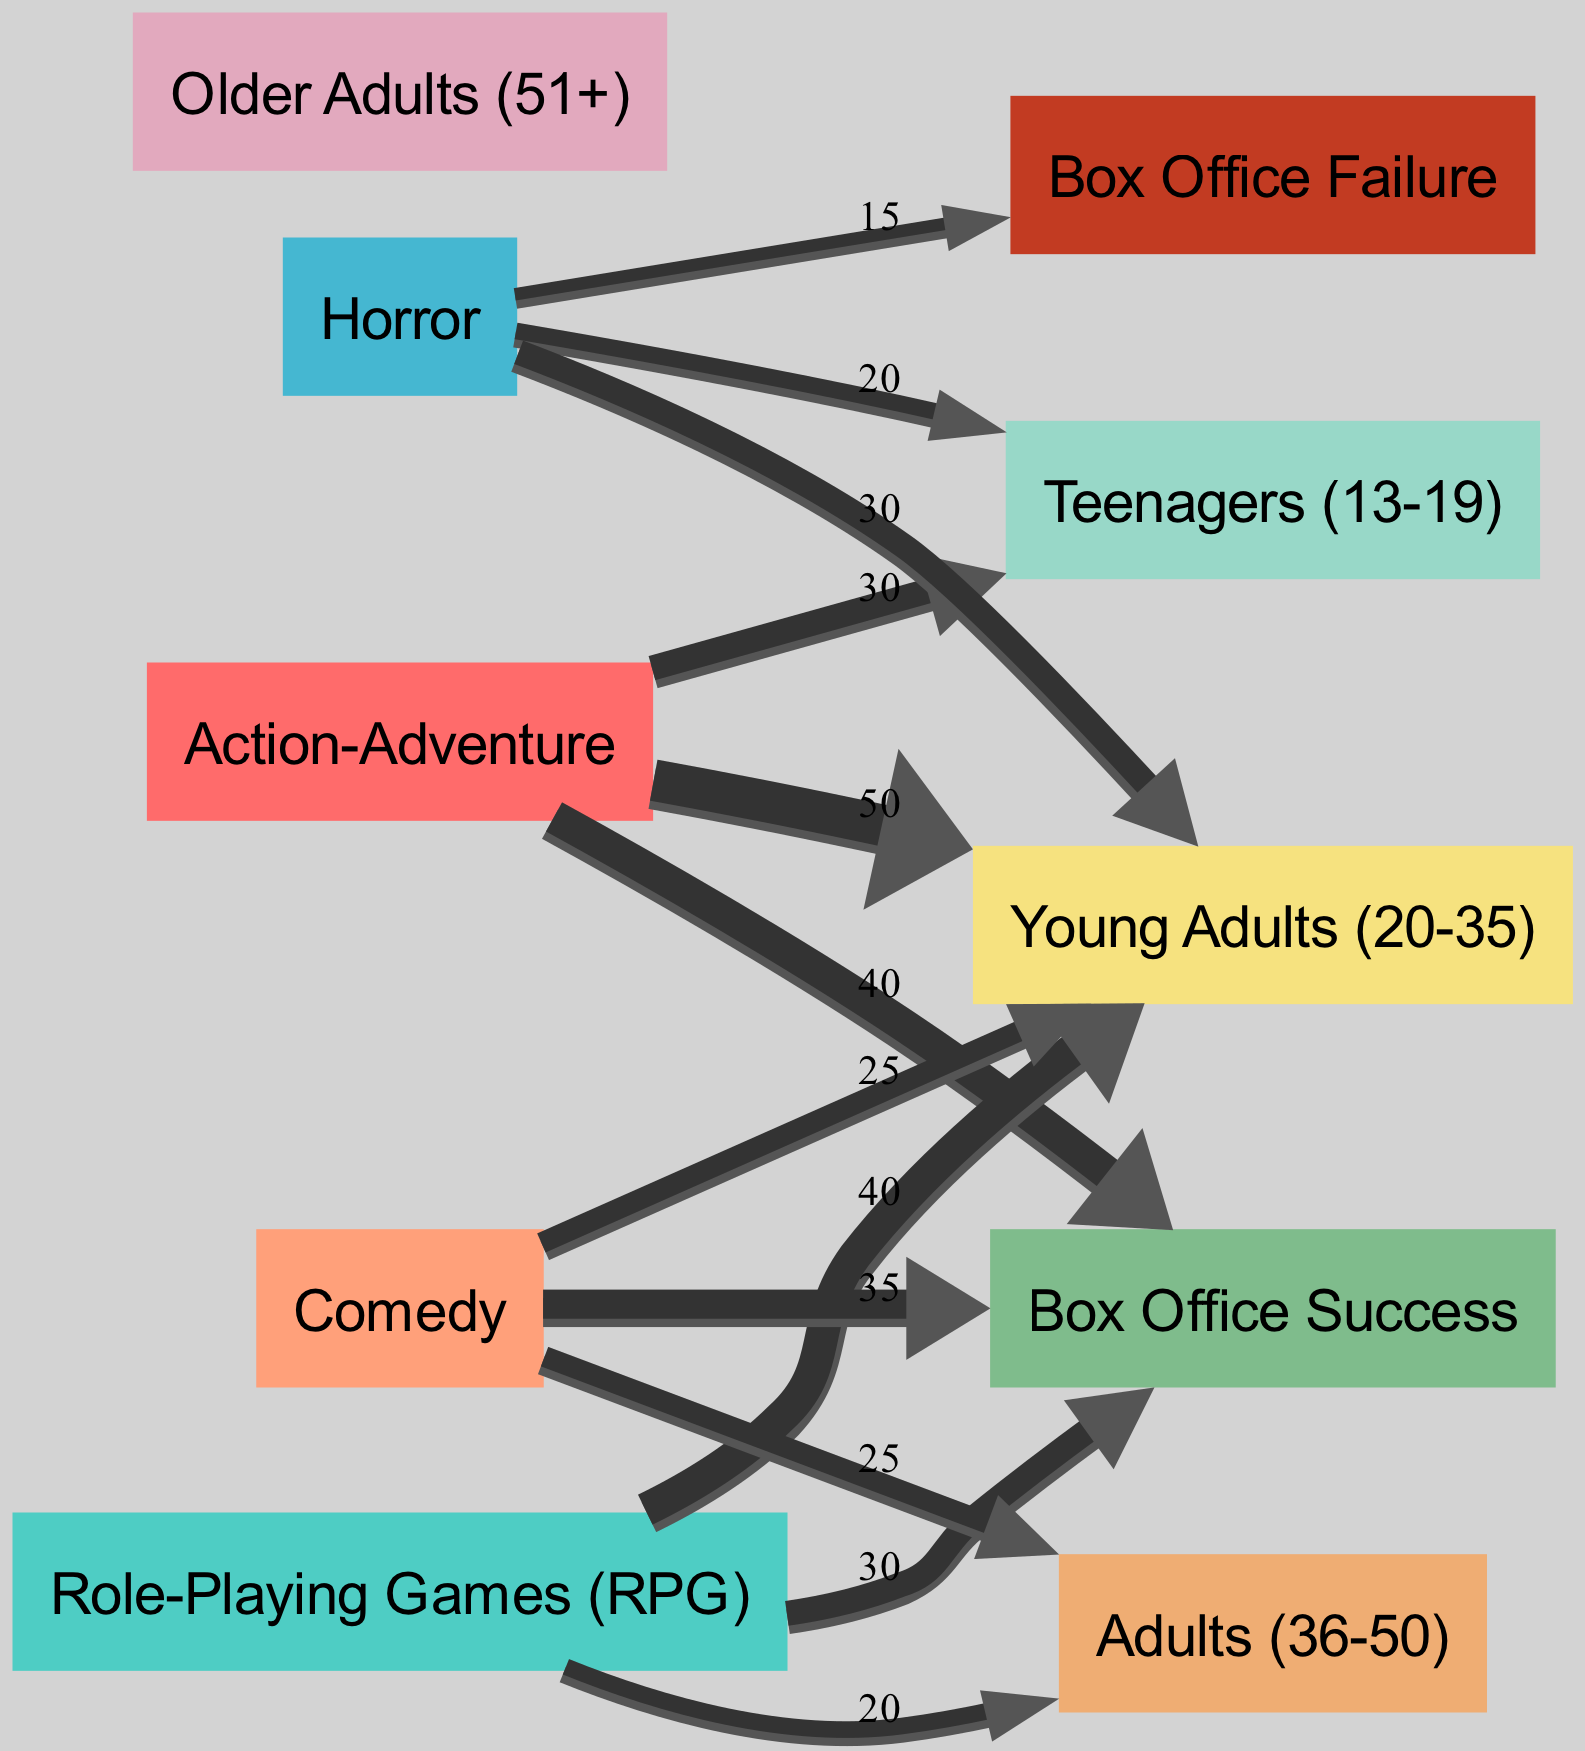What age group has the highest association with Action-Adventure films? By examining the outgoing connections from the Action-Adventure node, young adults have the highest value of 50, indicating they are the primary age group associated with this genre.
Answer: Young Adults What is the total number of edges in the diagram? There are four genres and two outcomes, with outgoing connections representing audience demographic values. The counted edges linking genres to demographics and outcomes total to ten edges depicted in the diagram.
Answer: 10 Which genre has the lowest value linked to Box Office Failure? The genre Horror has a value of 15 linked to Box Office Failure, which is the lowest among all genres represented in the diagram as it connects directly with that outcome.
Answer: Horror What is the value of teenagers associated with Horror films? The diagram shows that the connection from Horror to Teenagers has a value of 20, indicating the number of teenagers engaged with horror films.
Answer: 20 Which age group has the highest association with Comedy films? By analyzing the flows from the Comedy node, it can be noted that the Young Adults and Adults age groups both share a value of 25, but the total value flowing from Comedy indicates the highest demographic impact from young adults as they contribute heavily in the majority of cases.
Answer: Young Adults What is the total value of young adults in Comedy and RPG films combined? The Comedy films show a value of 25 for young adults and the RPG films show a value of 40. Adding these two values gives a total of 65 for young adults within both genres depicted in the diagram.
Answer: 65 What genre has the highest flow towards Box Office Success? The connections from the genre nodes toward Box Office Success indicate that Action-Adventure has the highest value of 40 flowing into this category, greatly surpassing other genres.
Answer: Action-Adventure Which age group contributes most to Box Office Success across all genres? Looking at the outgoing connections toward Box Office Success, the genre Action-Adventure contributes heavily with a significant audience demographic, but young adults collectively dominate across genres thereby leading to a greater contribution overall classified under Box Office Success.
Answer: Young Adults What percentage of Action-Adventure films are considered Box Office Success? The value for Action-Adventure films linked to Box Office Success is 40 out of a total of 120 across all genres, resulting in approximately 33% (40/120 * 100). To obtain an exact percentage, it would go through calculations based on given values in the diagram.
Answer: 33% 